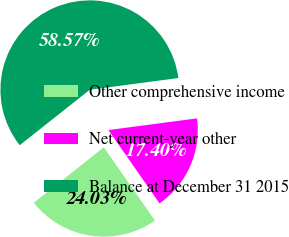Convert chart. <chart><loc_0><loc_0><loc_500><loc_500><pie_chart><fcel>Other comprehensive income<fcel>Net current-year other<fcel>Balance at December 31 2015<nl><fcel>24.03%<fcel>17.4%<fcel>58.57%<nl></chart> 